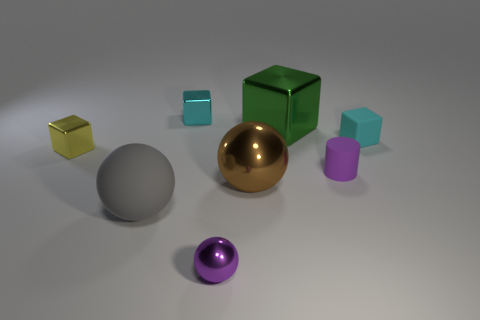Subtract all small blocks. How many blocks are left? 1 Subtract all cyan cylinders. How many cyan blocks are left? 2 Add 2 gray balls. How many objects exist? 10 Subtract all yellow blocks. How many blocks are left? 3 Subtract all cylinders. How many objects are left? 7 Subtract 2 blocks. How many blocks are left? 2 Add 1 big brown objects. How many big brown objects are left? 2 Add 1 big gray shiny spheres. How many big gray shiny spheres exist? 1 Subtract 0 yellow cylinders. How many objects are left? 8 Subtract all gray cylinders. Subtract all red balls. How many cylinders are left? 1 